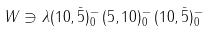Convert formula to latex. <formula><loc_0><loc_0><loc_500><loc_500>W \ni \lambda ( { 1 0 } , \bar { 5 } ) ^ { - } _ { 0 } \, ( { 5 } , { 1 0 } ) ^ { - } _ { 0 } \, ( { 1 0 } , \bar { 5 } ) ^ { - } _ { 0 }</formula> 